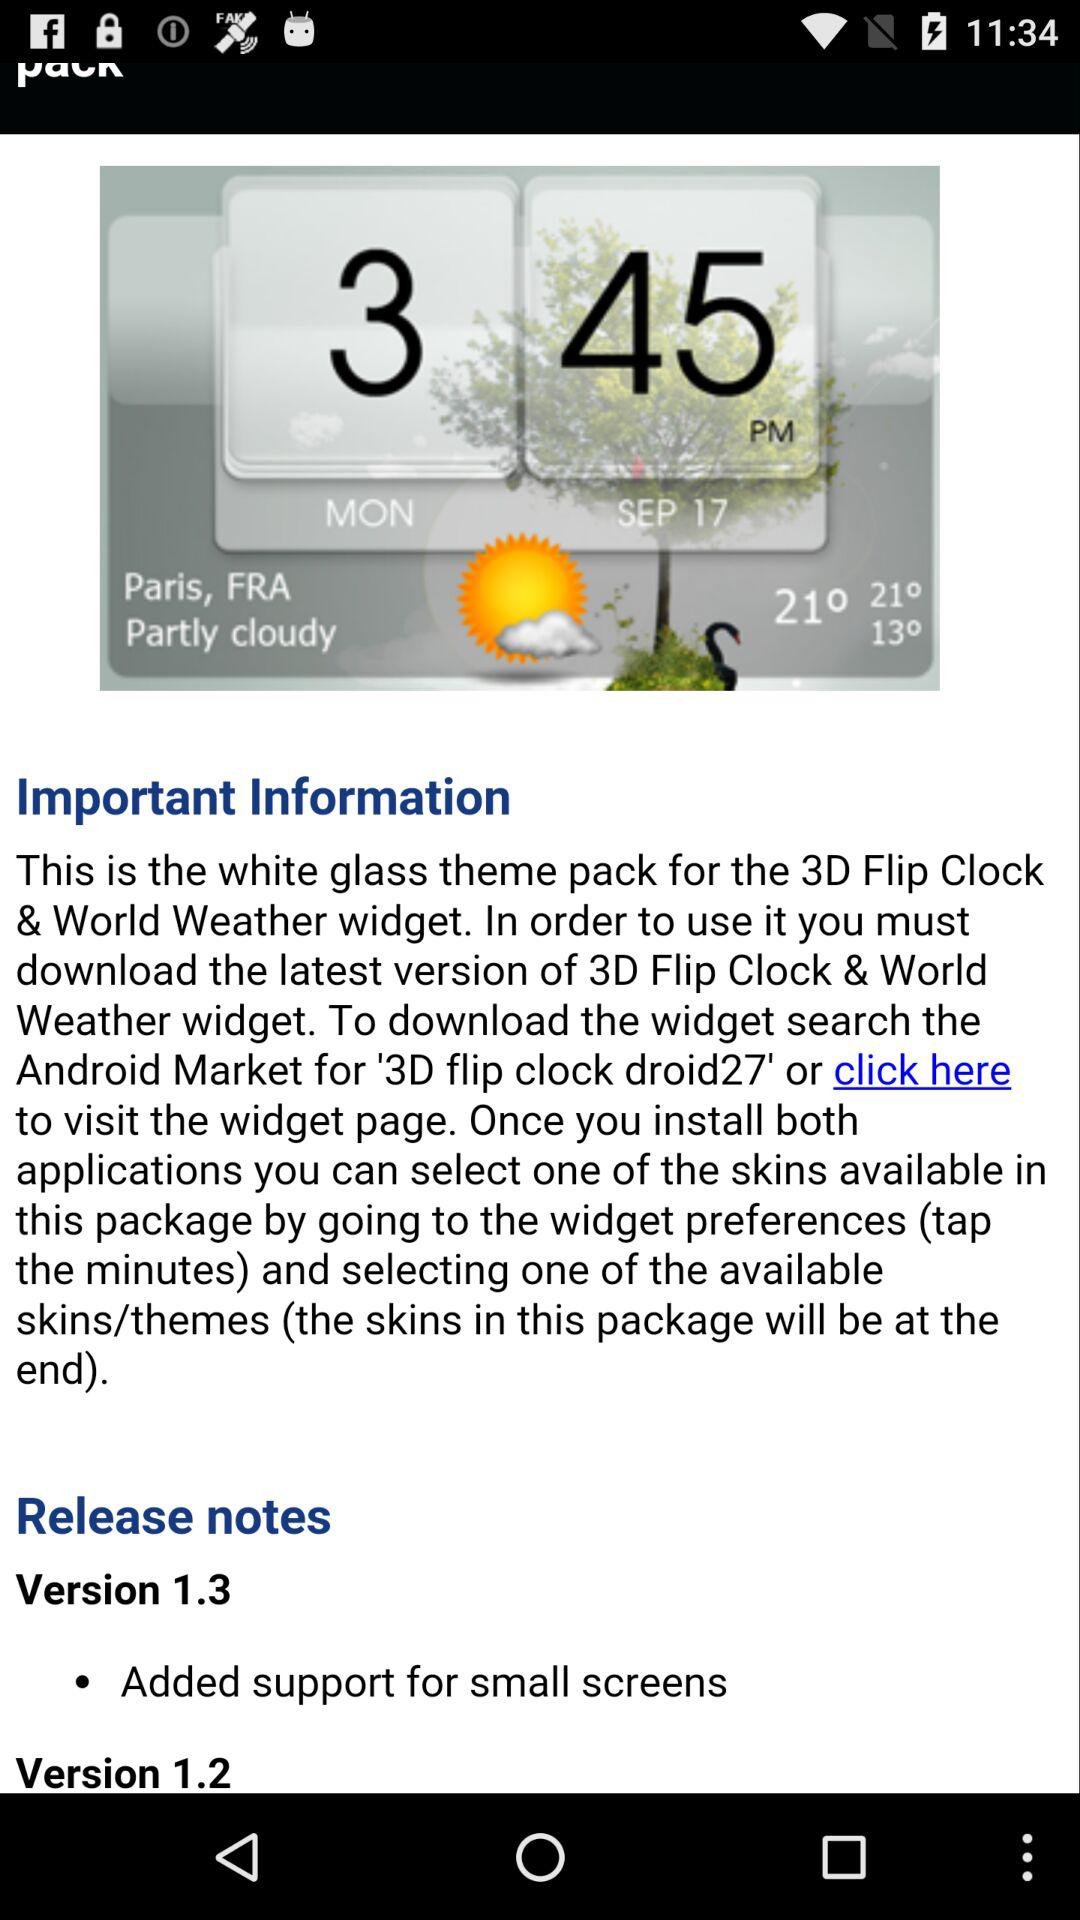How many versions of the theme pack are available?
Answer the question using a single word or phrase. 2 